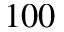<formula> <loc_0><loc_0><loc_500><loc_500>1 0 0</formula> 